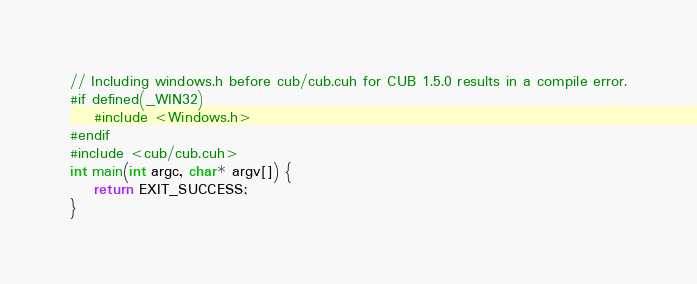Convert code to text. <code><loc_0><loc_0><loc_500><loc_500><_Cuda_>// Including windows.h before cub/cub.cuh for CUB 1.5.0 results in a compile error.
#if defined(_WIN32)
    #include <Windows.h>
#endif
#include <cub/cub.cuh>
int main(int argc, char* argv[]) {
    return EXIT_SUCCESS;
}
</code> 